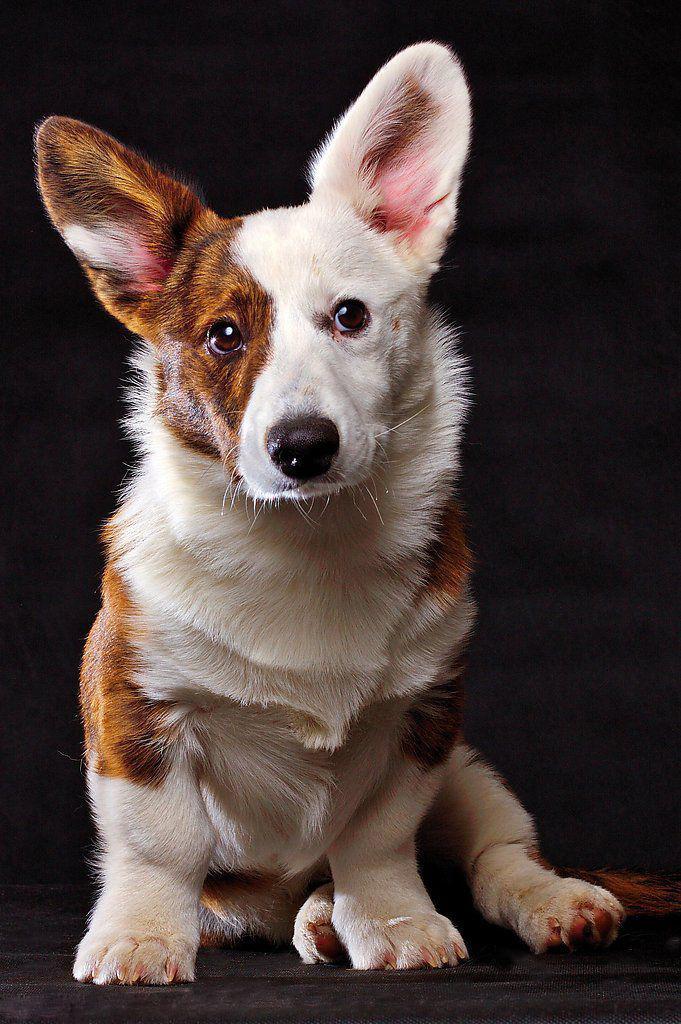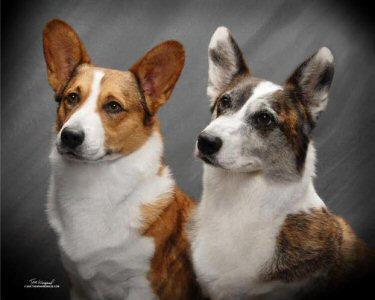The first image is the image on the left, the second image is the image on the right. Assess this claim about the two images: "There are exactly two dogs.". Correct or not? Answer yes or no. No. The first image is the image on the left, the second image is the image on the right. Given the left and right images, does the statement "There are at most two dogs." hold true? Answer yes or no. No. 